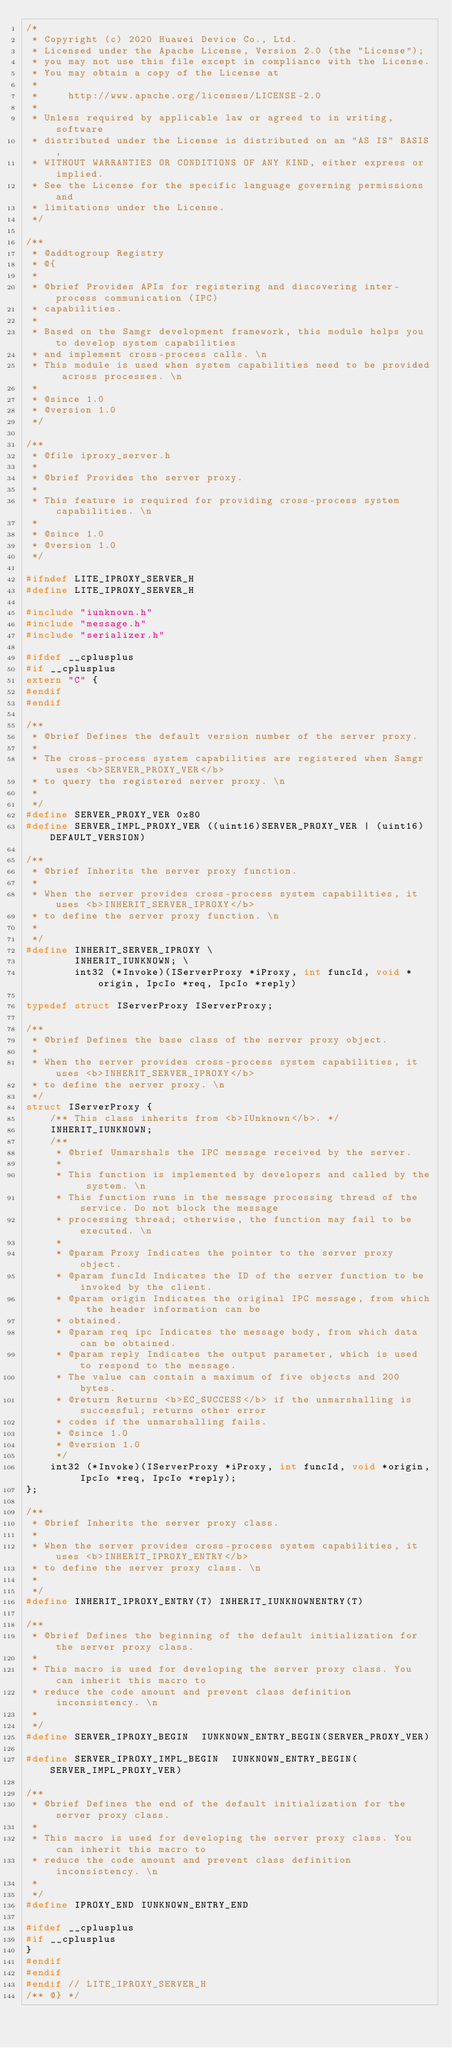Convert code to text. <code><loc_0><loc_0><loc_500><loc_500><_C_>/*
 * Copyright (c) 2020 Huawei Device Co., Ltd.
 * Licensed under the Apache License, Version 2.0 (the "License");
 * you may not use this file except in compliance with the License.
 * You may obtain a copy of the License at
 *
 *     http://www.apache.org/licenses/LICENSE-2.0
 *
 * Unless required by applicable law or agreed to in writing, software
 * distributed under the License is distributed on an "AS IS" BASIS,
 * WITHOUT WARRANTIES OR CONDITIONS OF ANY KIND, either express or implied.
 * See the License for the specific language governing permissions and
 * limitations under the License.
 */

/**
 * @addtogroup Registry
 * @{
 *
 * @brief Provides APIs for registering and discovering inter-process communication (IPC)
 * capabilities.
 *
 * Based on the Samgr development framework, this module helps you to develop system capabilities
 * and implement cross-process calls. \n
 * This module is used when system capabilities need to be provided across processes. \n
 *
 * @since 1.0
 * @version 1.0
 */

/**
 * @file iproxy_server.h
 *
 * @brief Provides the server proxy.
 *
 * This feature is required for providing cross-process system capabilities. \n
 *
 * @since 1.0
 * @version 1.0
 */

#ifndef LITE_IPROXY_SERVER_H
#define LITE_IPROXY_SERVER_H

#include "iunknown.h"
#include "message.h"
#include "serializer.h"

#ifdef __cplusplus
#if __cplusplus
extern "C" {
#endif
#endif

/**
 * @brief Defines the default version number of the server proxy.
 *
 * The cross-process system capabilities are registered when Samgr uses <b>SERVER_PROXY_VER</b>
 * to query the registered server proxy. \n
 *
 */
#define SERVER_PROXY_VER 0x80
#define SERVER_IMPL_PROXY_VER ((uint16)SERVER_PROXY_VER | (uint16)DEFAULT_VERSION)

/**
 * @brief Inherits the server proxy function.
 *
 * When the server provides cross-process system capabilities, it uses <b>INHERIT_SERVER_IPROXY</b>
 * to define the server proxy function. \n
 *
 */
#define INHERIT_SERVER_IPROXY \
        INHERIT_IUNKNOWN; \
        int32 (*Invoke)(IServerProxy *iProxy, int funcId, void *origin, IpcIo *req, IpcIo *reply)

typedef struct IServerProxy IServerProxy;

/**
 * @brief Defines the base class of the server proxy object.
 *
 * When the server provides cross-process system capabilities, it uses <b>INHERIT_SERVER_IPROXY</b>
 * to define the server proxy. \n
 */
struct IServerProxy {
    /** This class inherits from <b>IUnknown</b>. */
    INHERIT_IUNKNOWN;
    /**
     * @brief Unmarshals the IPC message received by the server.
     *
     * This function is implemented by developers and called by the system. \n
     * This function runs in the message processing thread of the service. Do not block the message
     * processing thread; otherwise, the function may fail to be executed. \n
     *
     * @param Proxy Indicates the pointer to the server proxy object.
     * @param funcId Indicates the ID of the server function to be invoked by the client.
     * @param origin Indicates the original IPC message, from which the header information can be
     * obtained.
     * @param req ipc Indicates the message body, from which data can be obtained.
     * @param reply Indicates the output parameter, which is used to respond to the message.
     * The value can contain a maximum of five objects and 200 bytes.
     * @return Returns <b>EC_SUCCESS</b> if the unmarshalling is successful; returns other error
     * codes if the unmarshalling fails.
     * @since 1.0
     * @version 1.0
     */
    int32 (*Invoke)(IServerProxy *iProxy, int funcId, void *origin, IpcIo *req, IpcIo *reply);
};

/**
 * @brief Inherits the server proxy class.
 *
 * When the server provides cross-process system capabilities, it uses <b>INHERIT_IPROXY_ENTRY</b>
 * to define the server proxy class. \n
 *
 */
#define INHERIT_IPROXY_ENTRY(T) INHERIT_IUNKNOWNENTRY(T)

/**
 * @brief Defines the beginning of the default initialization for the server proxy class.
 *
 * This macro is used for developing the server proxy class. You can inherit this macro to
 * reduce the code amount and prevent class definition inconsistency. \n
 *
 */
#define SERVER_IPROXY_BEGIN  IUNKNOWN_ENTRY_BEGIN(SERVER_PROXY_VER)

#define SERVER_IPROXY_IMPL_BEGIN  IUNKNOWN_ENTRY_BEGIN(SERVER_IMPL_PROXY_VER)

/**
 * @brief Defines the end of the default initialization for the server proxy class.
 *
 * This macro is used for developing the server proxy class. You can inherit this macro to
 * reduce the code amount and prevent class definition inconsistency. \n
 *
 */
#define IPROXY_END IUNKNOWN_ENTRY_END

#ifdef __cplusplus
#if __cplusplus
}
#endif
#endif
#endif // LITE_IPROXY_SERVER_H
/** @} */
</code> 